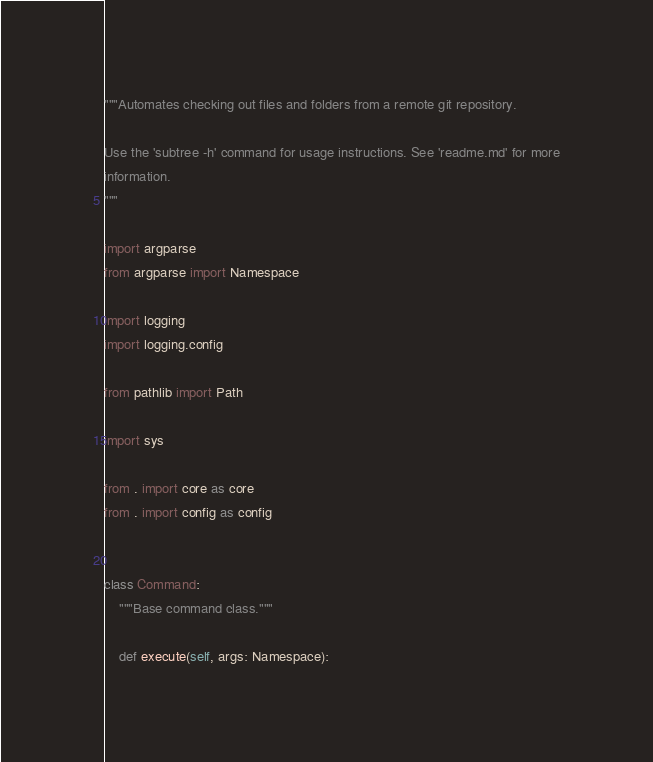<code> <loc_0><loc_0><loc_500><loc_500><_Python_>"""Automates checking out files and folders from a remote git repository.

Use the 'subtree -h' command for usage instructions. See 'readme.md' for more
information.
"""

import argparse
from argparse import Namespace

import logging
import logging.config

from pathlib import Path

import sys

from . import core as core
from . import config as config


class Command:
    """Base command class."""

    def execute(self, args: Namespace):</code> 